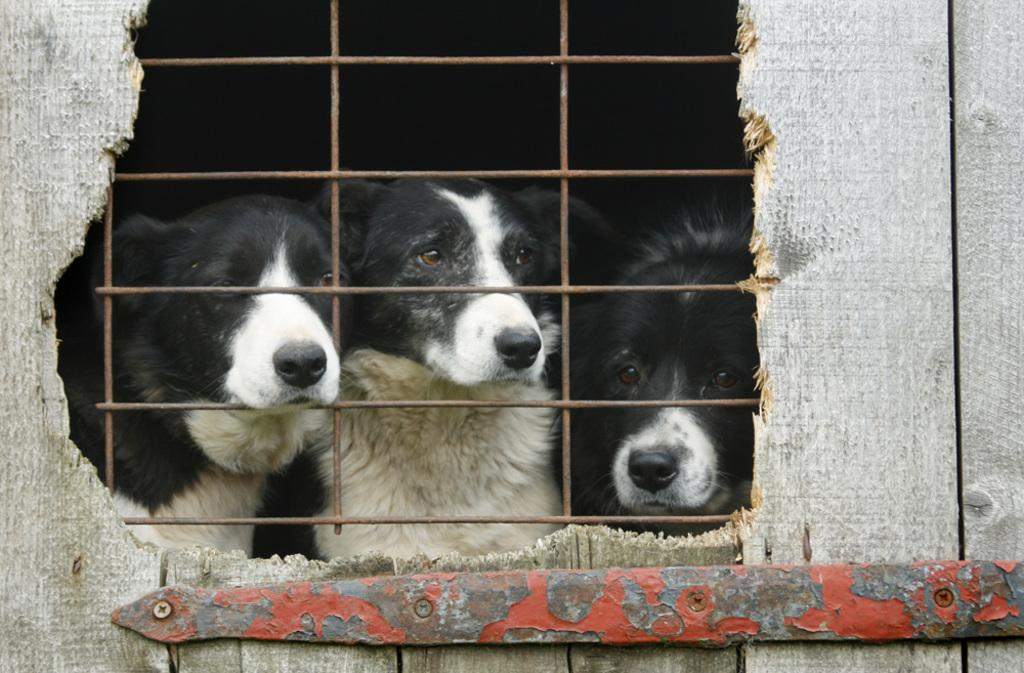What is the material of the door in the image? The door in the image is made of wood. What is attached to the wooden door? There is a metal item on the wooden door. What is the condition of the metal item? The metal item is broken. Where are the dogs located in the image? The dogs are at the welded mesh wire. Can you see any boats in the image? There are no boats present in the image. Are the dogs wearing skates in the image? There is no indication of skates or any footwear on the dogs in the image. 